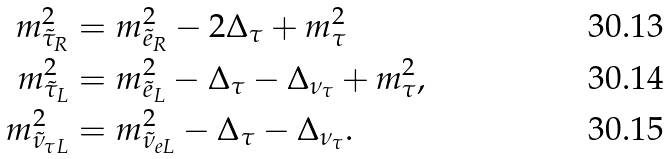Convert formula to latex. <formula><loc_0><loc_0><loc_500><loc_500>m ^ { 2 } _ { \tilde { \tau } _ { R } } & = m ^ { 2 } _ { \tilde { e } _ { R } } - 2 \Delta _ { \tau } + m ^ { 2 } _ { \tau } \\ m ^ { 2 } _ { \tilde { \tau } _ { L } } & = m ^ { 2 } _ { \tilde { e } _ { L } } - \Delta _ { \tau } - \Delta _ { \nu _ { \tau } } + m ^ { 2 } _ { \tau } , \\ m ^ { 2 } _ { \tilde { \nu } _ { \tau L } } & = m ^ { 2 } _ { \tilde { \nu } _ { e L } } - \Delta _ { \tau } - \Delta _ { \nu _ { \tau } } .</formula> 